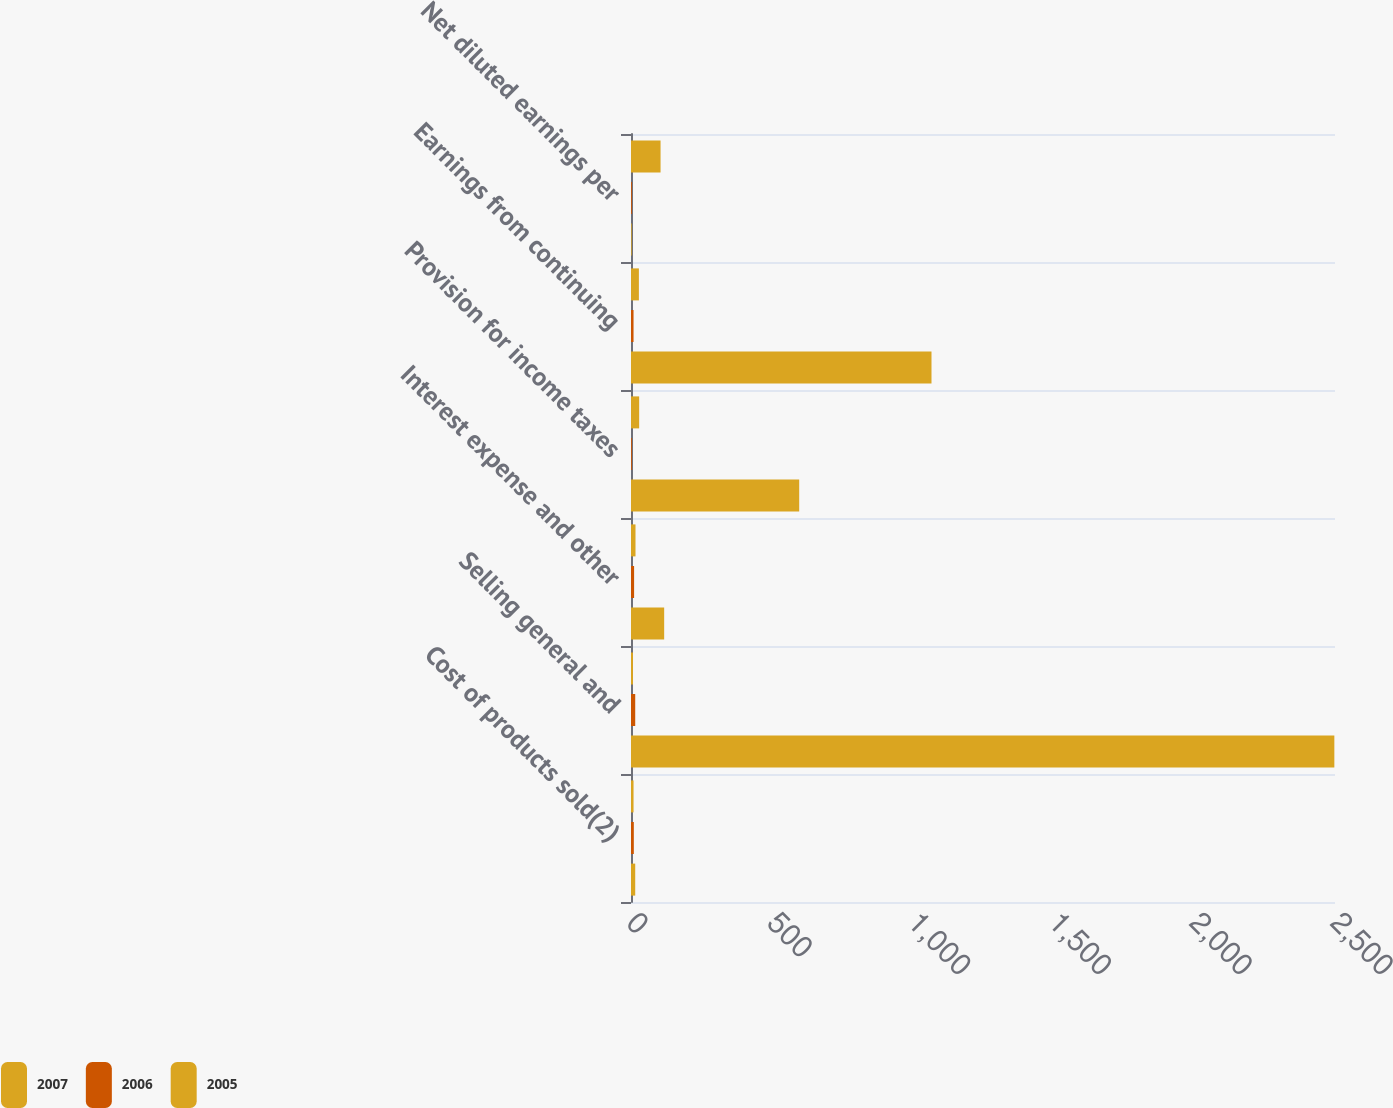Convert chart. <chart><loc_0><loc_0><loc_500><loc_500><stacked_bar_chart><ecel><fcel>Cost of products sold(2)<fcel>Selling general and<fcel>Interest expense and other<fcel>Provision for income taxes<fcel>Earnings from continuing<fcel>Net diluted earnings per<nl><fcel>2007<fcel>9<fcel>7<fcel>16<fcel>29<fcel>28<fcel>105<nl><fcel>2006<fcel>10<fcel>15<fcel>11<fcel>3<fcel>9<fcel>3<nl><fcel>2005<fcel>15<fcel>2497.7<fcel>117.8<fcel>597.3<fcel>1067.1<fcel>2.41<nl></chart> 